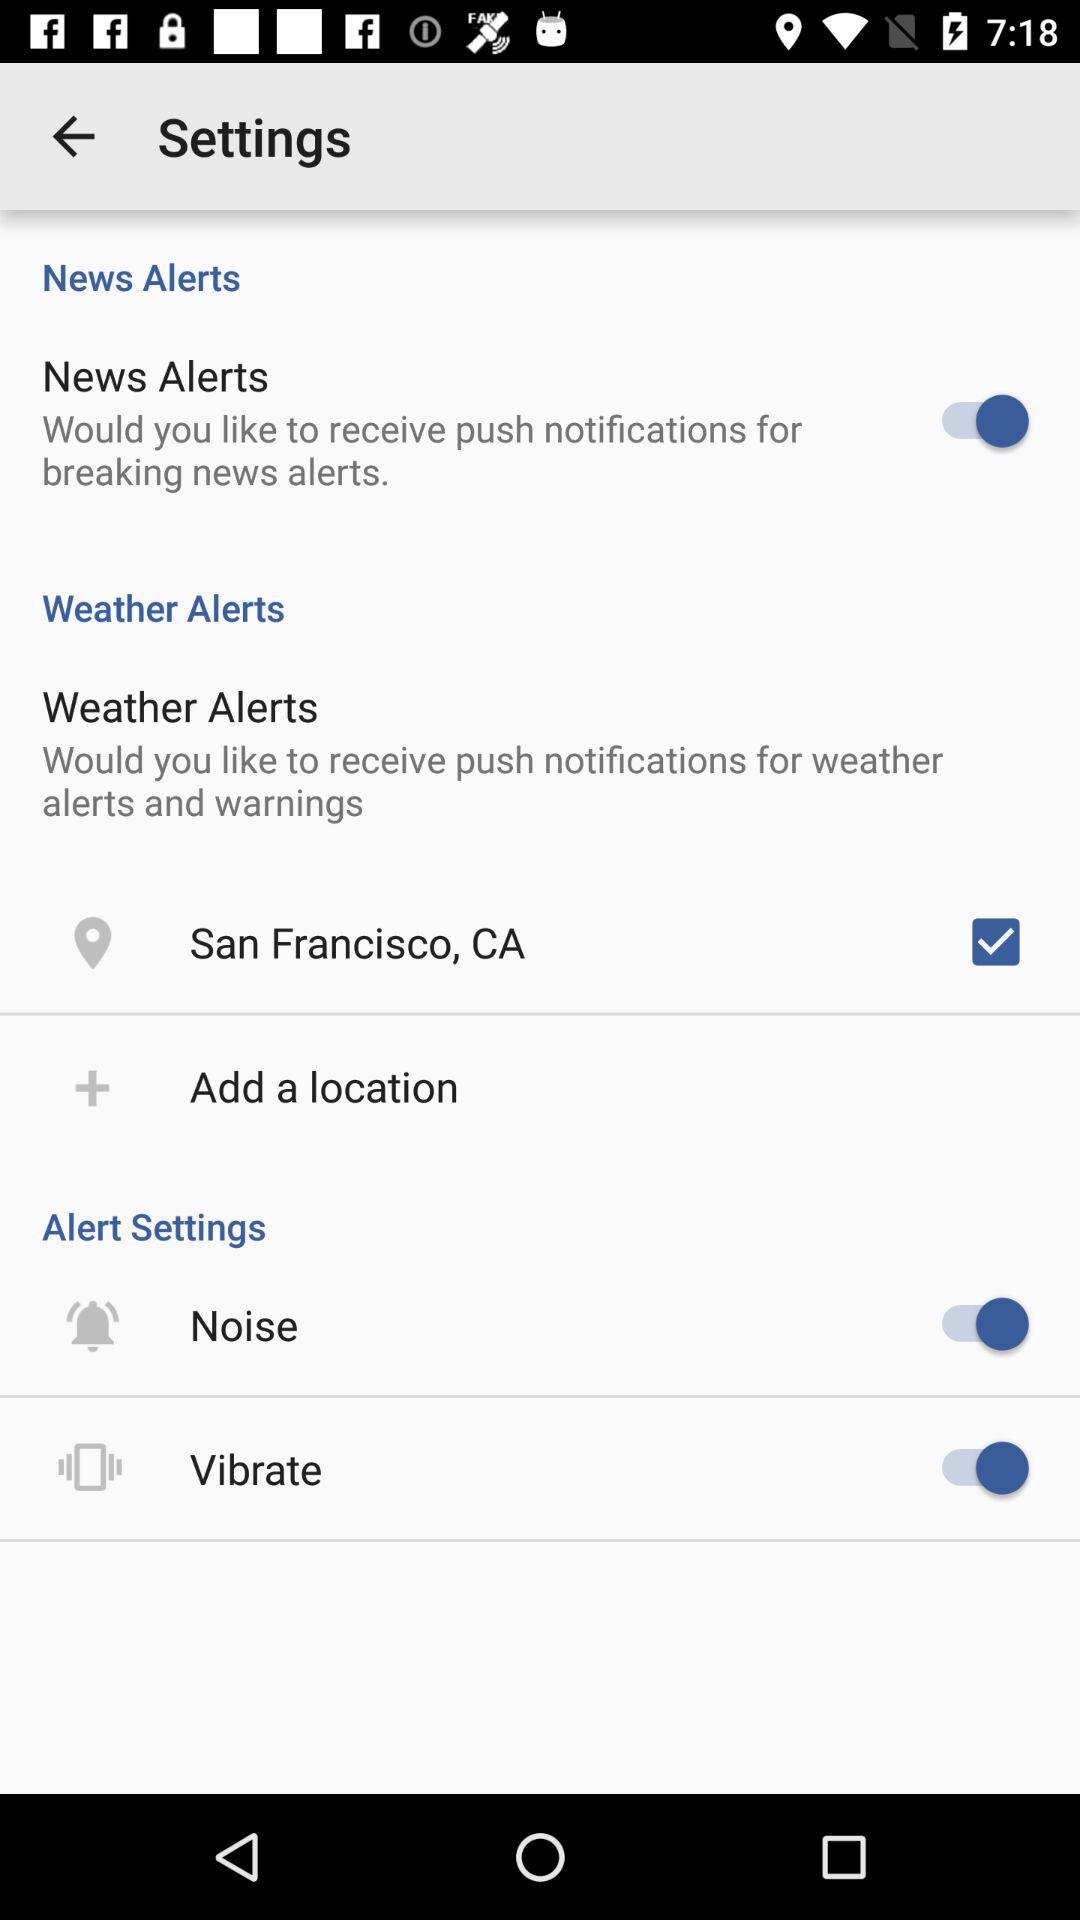What is the status of "News Alerts"? The status is "on". 